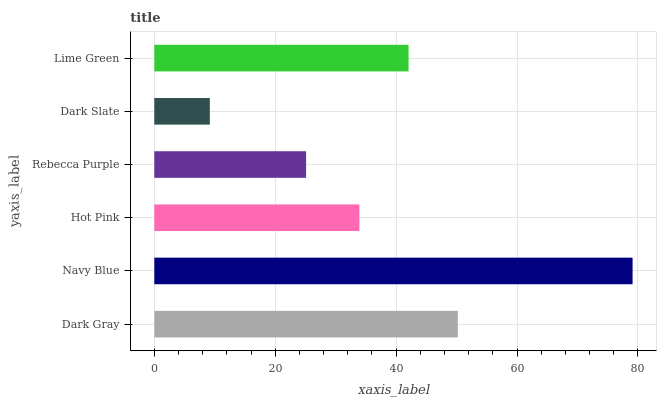Is Dark Slate the minimum?
Answer yes or no. Yes. Is Navy Blue the maximum?
Answer yes or no. Yes. Is Hot Pink the minimum?
Answer yes or no. No. Is Hot Pink the maximum?
Answer yes or no. No. Is Navy Blue greater than Hot Pink?
Answer yes or no. Yes. Is Hot Pink less than Navy Blue?
Answer yes or no. Yes. Is Hot Pink greater than Navy Blue?
Answer yes or no. No. Is Navy Blue less than Hot Pink?
Answer yes or no. No. Is Lime Green the high median?
Answer yes or no. Yes. Is Hot Pink the low median?
Answer yes or no. Yes. Is Hot Pink the high median?
Answer yes or no. No. Is Lime Green the low median?
Answer yes or no. No. 